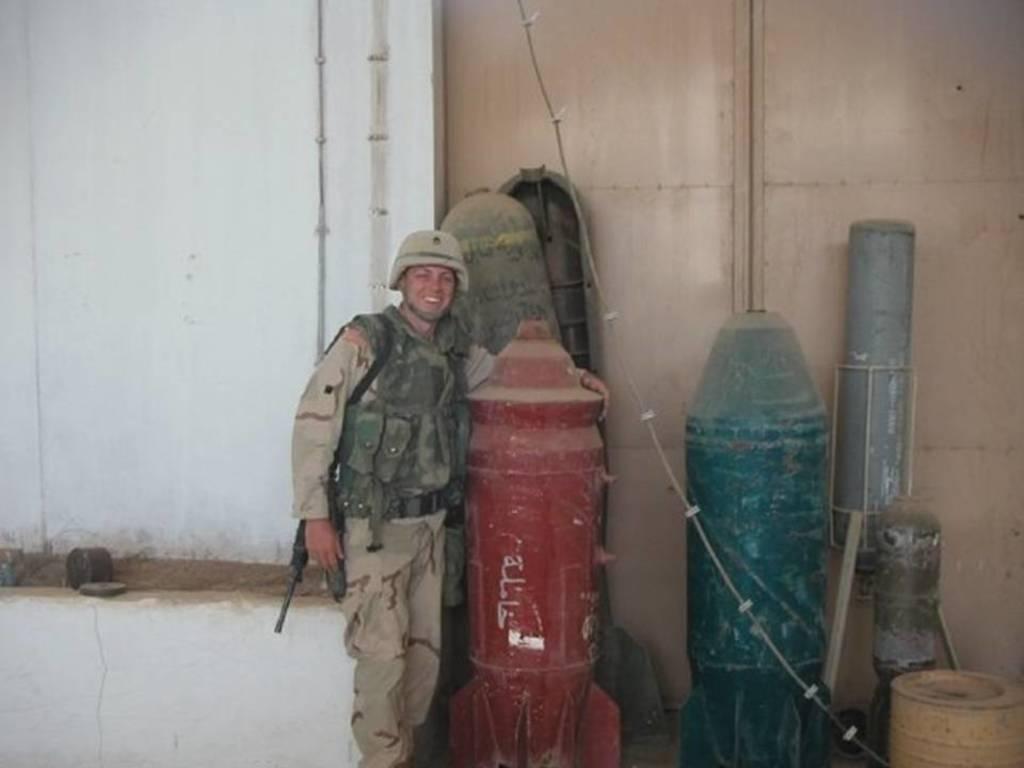In one or two sentences, can you explain what this image depicts? In the center of the image there is a person standing wearing a helmet beside him there are missiles. In the background of the image there is a wall. There is a gate. 